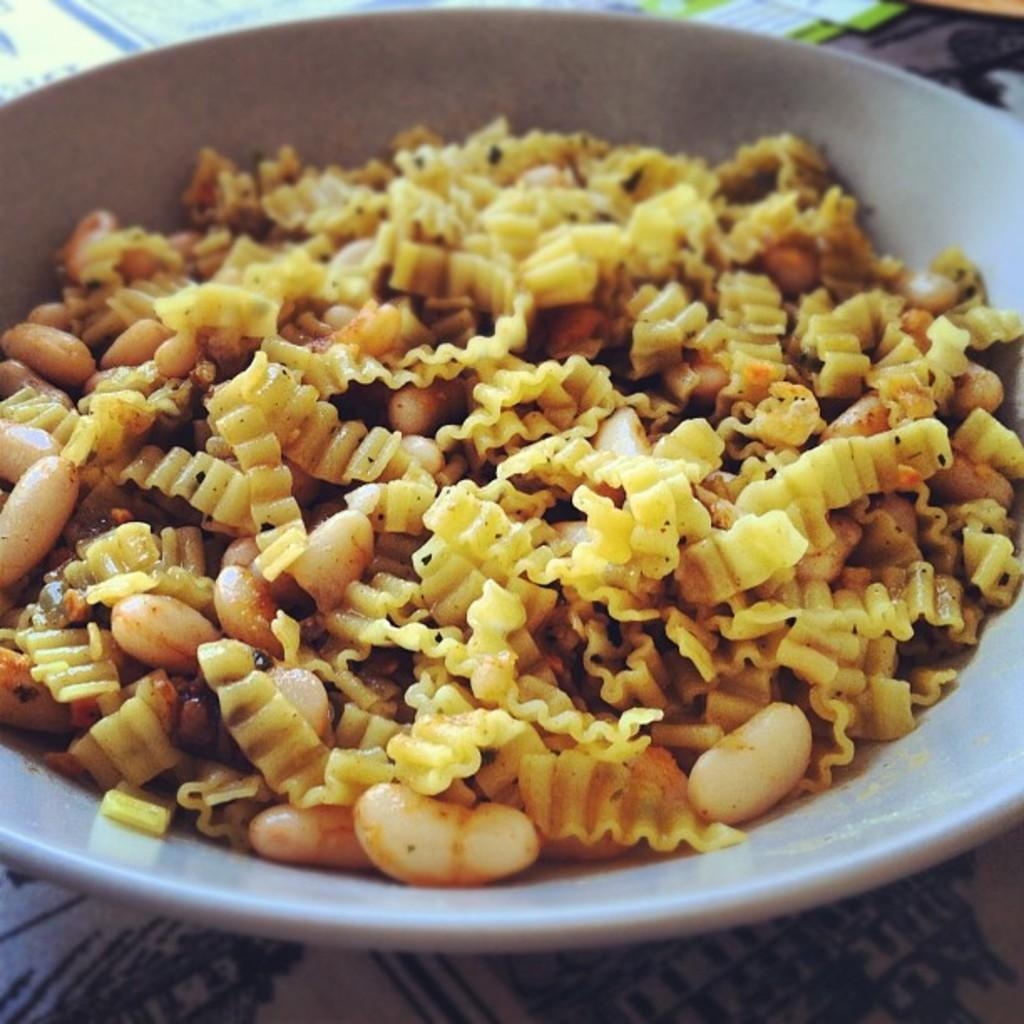What is the main object in the center of the image? There is a table in the center of the image. What is placed on the table? There is a bowl on the table. What is inside the bowl? There is a food item in the bowl. What type of animal can be seen making a statement in the image? There is no animal present in the image, and no one is making a statement. 